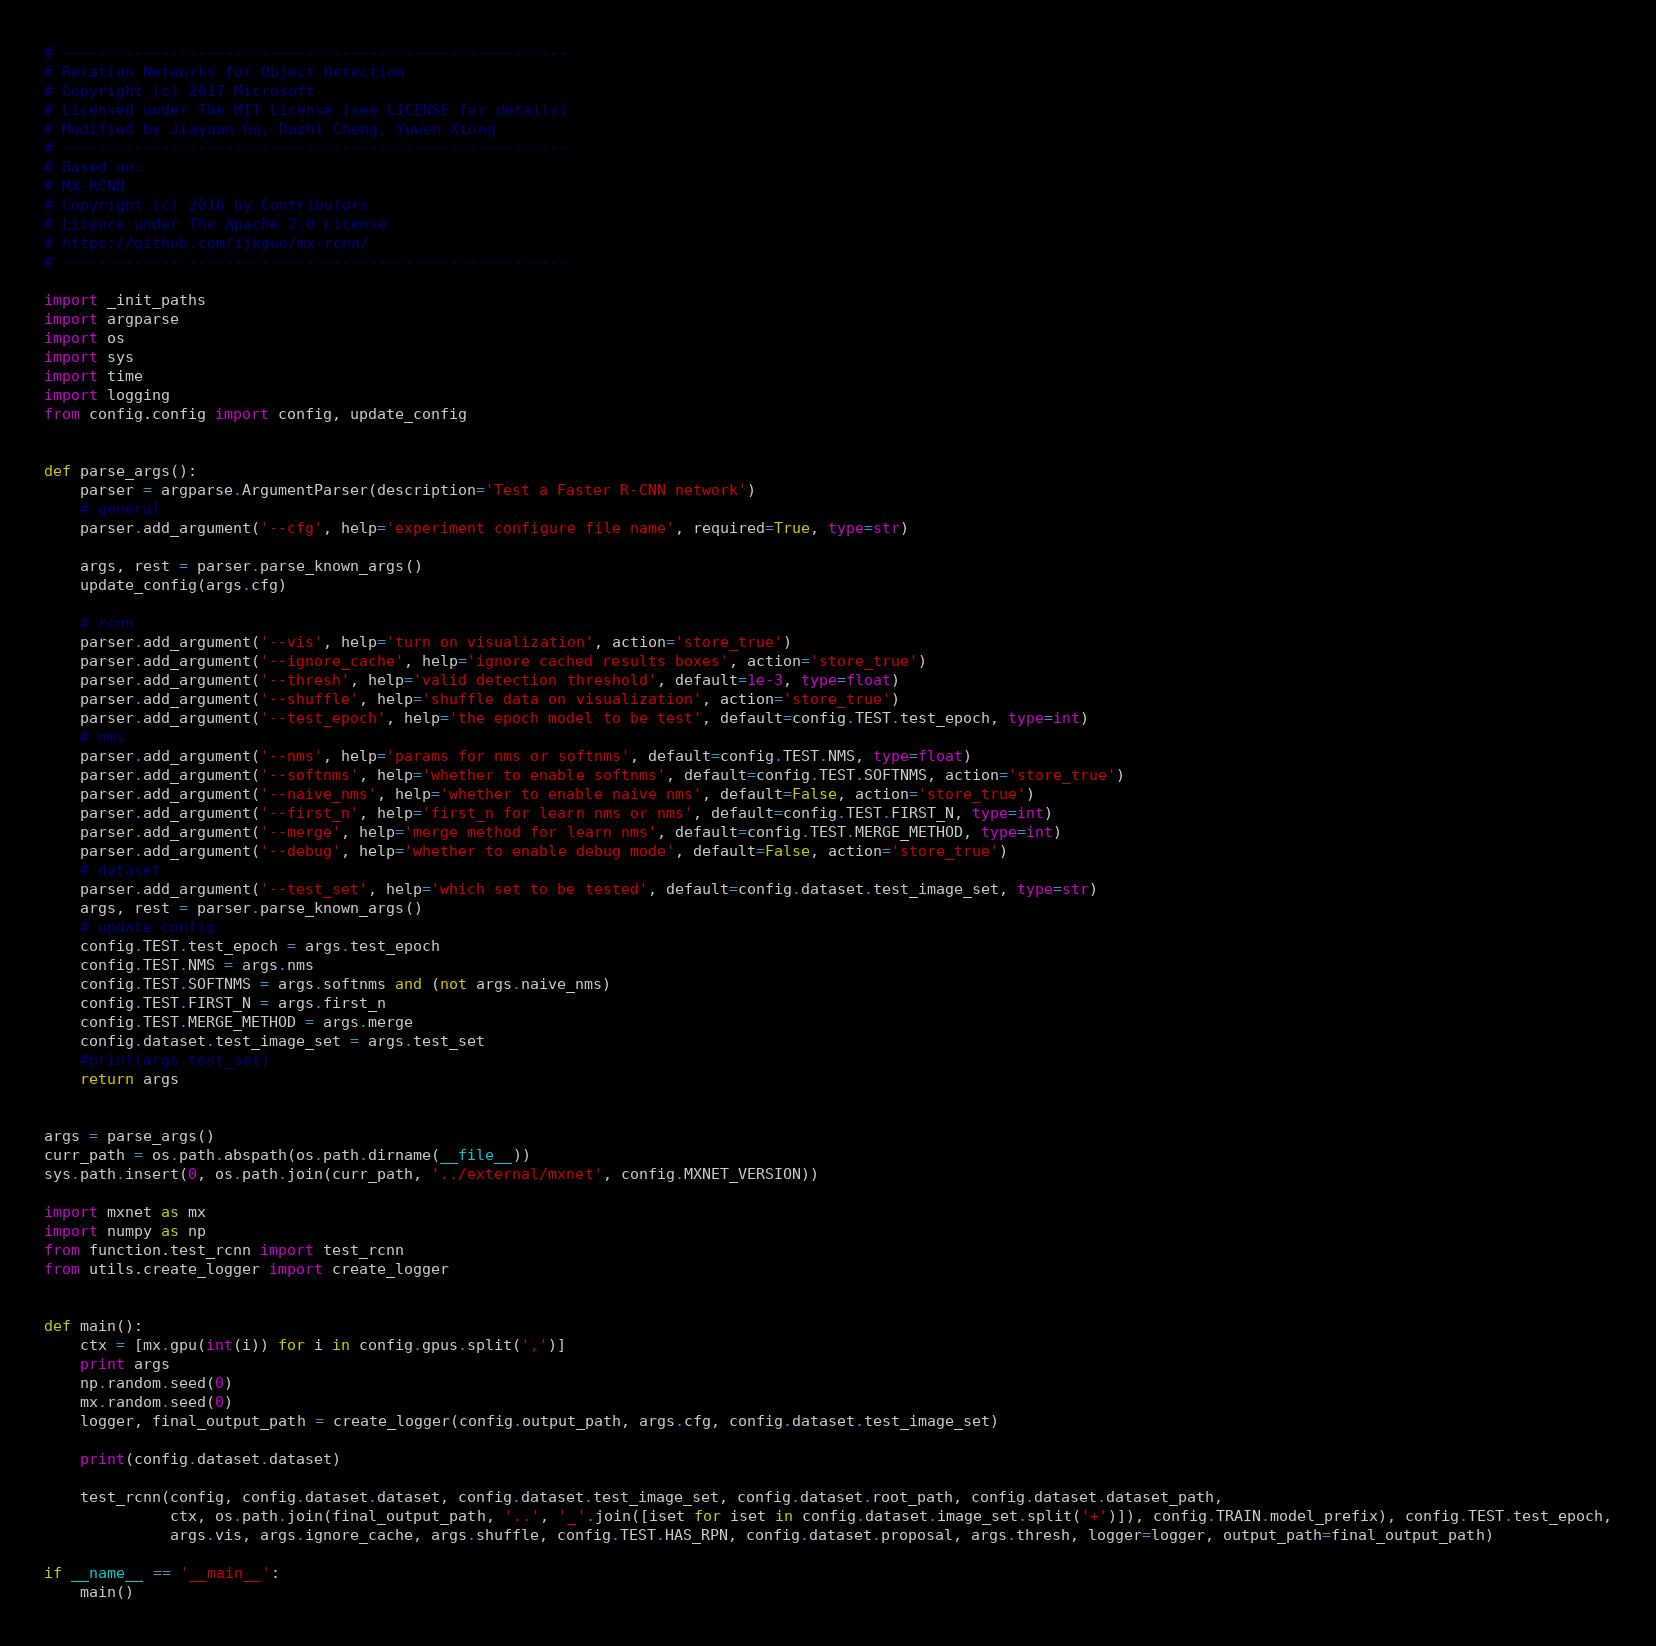Convert code to text. <code><loc_0><loc_0><loc_500><loc_500><_Python_># --------------------------------------------------------
# Relation Networks for Object Detection
# Copyright (c) 2017 Microsoft
# Licensed under The MIT License [see LICENSE for details]
# Modified by Jiayuan Gu, Dazhi Cheng, Yuwen Xiong
# --------------------------------------------------------
# Based on:
# MX-RCNN
# Copyright (c) 2016 by Contributors
# Licence under The Apache 2.0 License
# https://github.com/ijkguo/mx-rcnn/
# --------------------------------------------------------

import _init_paths
import argparse
import os
import sys
import time
import logging
from config.config import config, update_config


def parse_args():
    parser = argparse.ArgumentParser(description='Test a Faster R-CNN network')
    # general
    parser.add_argument('--cfg', help='experiment configure file name', required=True, type=str)

    args, rest = parser.parse_known_args()
    update_config(args.cfg)

    # rcnn
    parser.add_argument('--vis', help='turn on visualization', action='store_true')
    parser.add_argument('--ignore_cache', help='ignore cached results boxes', action='store_true')
    parser.add_argument('--thresh', help='valid detection threshold', default=1e-3, type=float)
    parser.add_argument('--shuffle', help='shuffle data on visualization', action='store_true')
    parser.add_argument('--test_epoch', help='the epoch model to be test', default=config.TEST.test_epoch, type=int)
    # nms
    parser.add_argument('--nms', help='params for nms or softnms', default=config.TEST.NMS, type=float)
    parser.add_argument('--softnms', help='whether to enable softnms', default=config.TEST.SOFTNMS, action='store_true')
    parser.add_argument('--naive_nms', help='whether to enable naive nms', default=False, action='store_true')
    parser.add_argument('--first_n', help='first_n for learn nms or nms', default=config.TEST.FIRST_N, type=int)
    parser.add_argument('--merge', help='merge method for learn nms', default=config.TEST.MERGE_METHOD, type=int)
    parser.add_argument('--debug', help='whether to enable debug mode', default=False, action='store_true')
    # dataset
    parser.add_argument('--test_set', help='which set to be tested', default=config.dataset.test_image_set, type=str)
    args, rest = parser.parse_known_args()
    # update config
    config.TEST.test_epoch = args.test_epoch
    config.TEST.NMS = args.nms
    config.TEST.SOFTNMS = args.softnms and (not args.naive_nms)
    config.TEST.FIRST_N = args.first_n
    config.TEST.MERGE_METHOD = args.merge
    config.dataset.test_image_set = args.test_set
    #print(args.test_set)
    return args


args = parse_args()
curr_path = os.path.abspath(os.path.dirname(__file__))
sys.path.insert(0, os.path.join(curr_path, '../external/mxnet', config.MXNET_VERSION))

import mxnet as mx
import numpy as np
from function.test_rcnn import test_rcnn
from utils.create_logger import create_logger


def main():
    ctx = [mx.gpu(int(i)) for i in config.gpus.split(',')]
    print args
    np.random.seed(0)
    mx.random.seed(0)
    logger, final_output_path = create_logger(config.output_path, args.cfg, config.dataset.test_image_set)

    print(config.dataset.dataset)

    test_rcnn(config, config.dataset.dataset, config.dataset.test_image_set, config.dataset.root_path, config.dataset.dataset_path,
              ctx, os.path.join(final_output_path, '..', '_'.join([iset for iset in config.dataset.image_set.split('+')]), config.TRAIN.model_prefix), config.TEST.test_epoch,
              args.vis, args.ignore_cache, args.shuffle, config.TEST.HAS_RPN, config.dataset.proposal, args.thresh, logger=logger, output_path=final_output_path)

if __name__ == '__main__':
    main()
</code> 